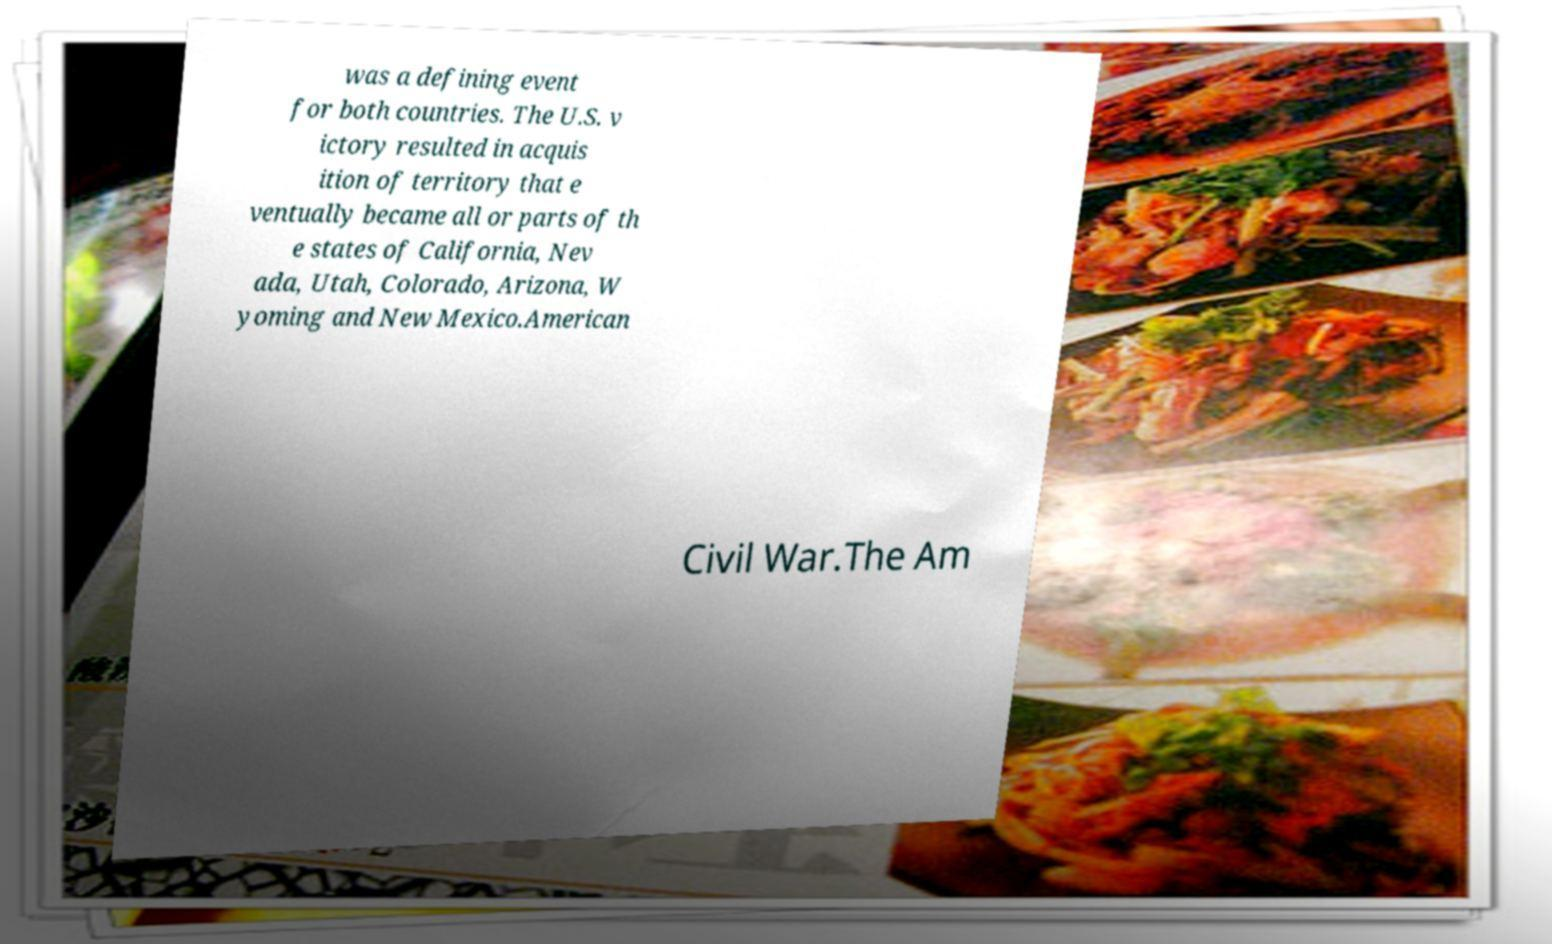Please read and relay the text visible in this image. What does it say? was a defining event for both countries. The U.S. v ictory resulted in acquis ition of territory that e ventually became all or parts of th e states of California, Nev ada, Utah, Colorado, Arizona, W yoming and New Mexico.American Civil War.The Am 